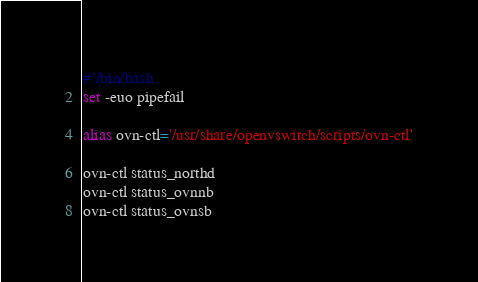<code> <loc_0><loc_0><loc_500><loc_500><_Bash_>#!/bin/bash
set -euo pipefail

alias ovn-ctl='/usr/share/openvswitch/scripts/ovn-ctl'

ovn-ctl status_northd
ovn-ctl status_ovnnb
ovn-ctl status_ovnsb
</code> 